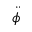<formula> <loc_0><loc_0><loc_500><loc_500>\ddot { \phi }</formula> 